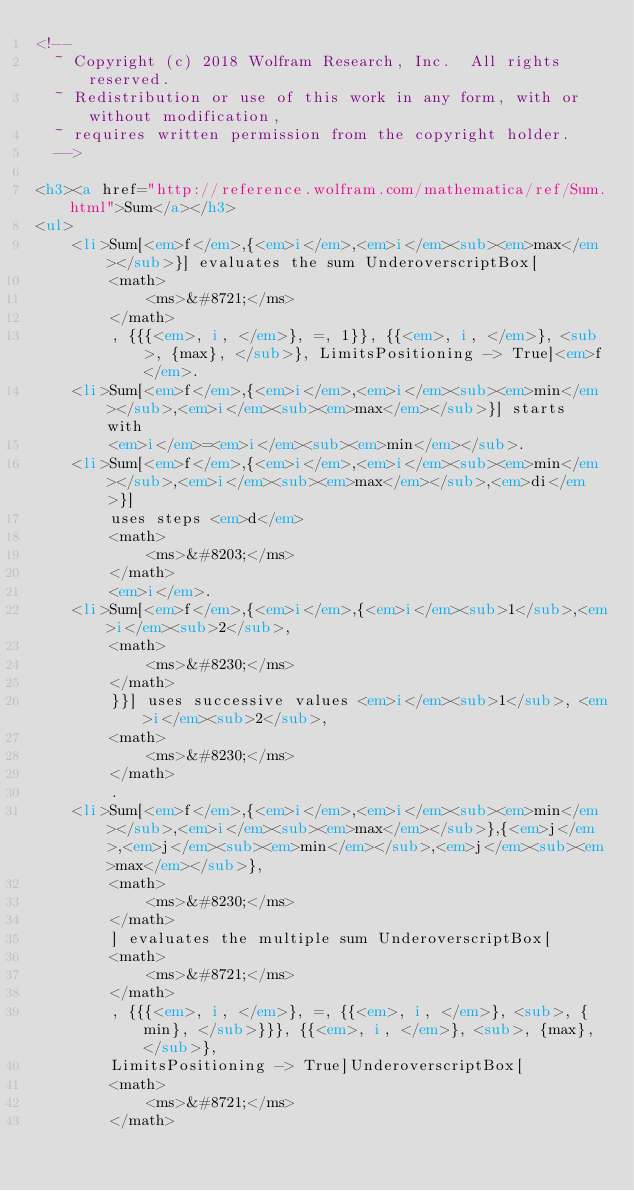Convert code to text. <code><loc_0><loc_0><loc_500><loc_500><_HTML_><!--
  ~ Copyright (c) 2018 Wolfram Research, Inc.  All rights reserved.
  ~ Redistribution or use of this work in any form, with or without modification,
  ~ requires written permission from the copyright holder.
  -->

<h3><a href="http://reference.wolfram.com/mathematica/ref/Sum.html">Sum</a></h3>
<ul>
    <li>Sum[<em>f</em>,{<em>i</em>,<em>i</em><sub><em>max</em></sub>}] evaluates the sum UnderoverscriptBox[
        <math>
            <ms>&#8721;</ms>
        </math>
        , {{{<em>, i, </em>}, =, 1}}, {{<em>, i, </em>}, <sub>, {max}, </sub>}, LimitsPositioning -> True]<em>f</em>.
    <li>Sum[<em>f</em>,{<em>i</em>,<em>i</em><sub><em>min</em></sub>,<em>i</em><sub><em>max</em></sub>}] starts with
        <em>i</em>=<em>i</em><sub><em>min</em></sub>.
    <li>Sum[<em>f</em>,{<em>i</em>,<em>i</em><sub><em>min</em></sub>,<em>i</em><sub><em>max</em></sub>,<em>di</em>}]
        uses steps <em>d</em>
        <math>
            <ms>&#8203;</ms>
        </math>
        <em>i</em>.
    <li>Sum[<em>f</em>,{<em>i</em>,{<em>i</em><sub>1</sub>,<em>i</em><sub>2</sub>,
        <math>
            <ms>&#8230;</ms>
        </math>
        }}] uses successive values <em>i</em><sub>1</sub>, <em>i</em><sub>2</sub>,
        <math>
            <ms>&#8230;</ms>
        </math>
        .
    <li>Sum[<em>f</em>,{<em>i</em>,<em>i</em><sub><em>min</em></sub>,<em>i</em><sub><em>max</em></sub>},{<em>j</em>,<em>j</em><sub><em>min</em></sub>,<em>j</em><sub><em>max</em></sub>},
        <math>
            <ms>&#8230;</ms>
        </math>
        ] evaluates the multiple sum UnderoverscriptBox[
        <math>
            <ms>&#8721;</ms>
        </math>
        , {{{<em>, i, </em>}, =, {{<em>, i, </em>}, <sub>, {min}, </sub>}}}, {{<em>, i, </em>}, <sub>, {max}, </sub>},
        LimitsPositioning -> True]UnderoverscriptBox[
        <math>
            <ms>&#8721;</ms>
        </math></code> 